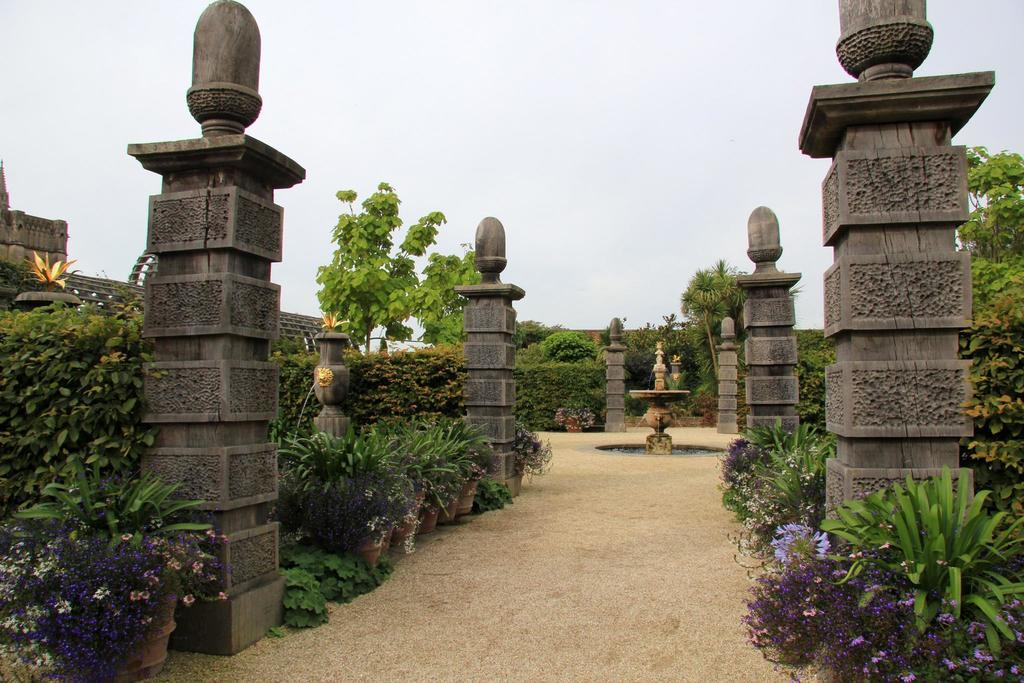What type of structures are present in the image? There are many pillars in the image. What type of natural elements are present in the image? There are many trees and plants in the image. What type of water feature can be seen in the image? There is a fountain in the image. What is the condition of the sky in the image? The sky is clear in the image. Can you tell me how many friends are sitting on the fountain in the image? There are no friends present in the image; it features pillars, trees, plants, and a fountain. What effect does the airport have on the image? There is no airport present in the image, so it cannot have any effect on the image. 